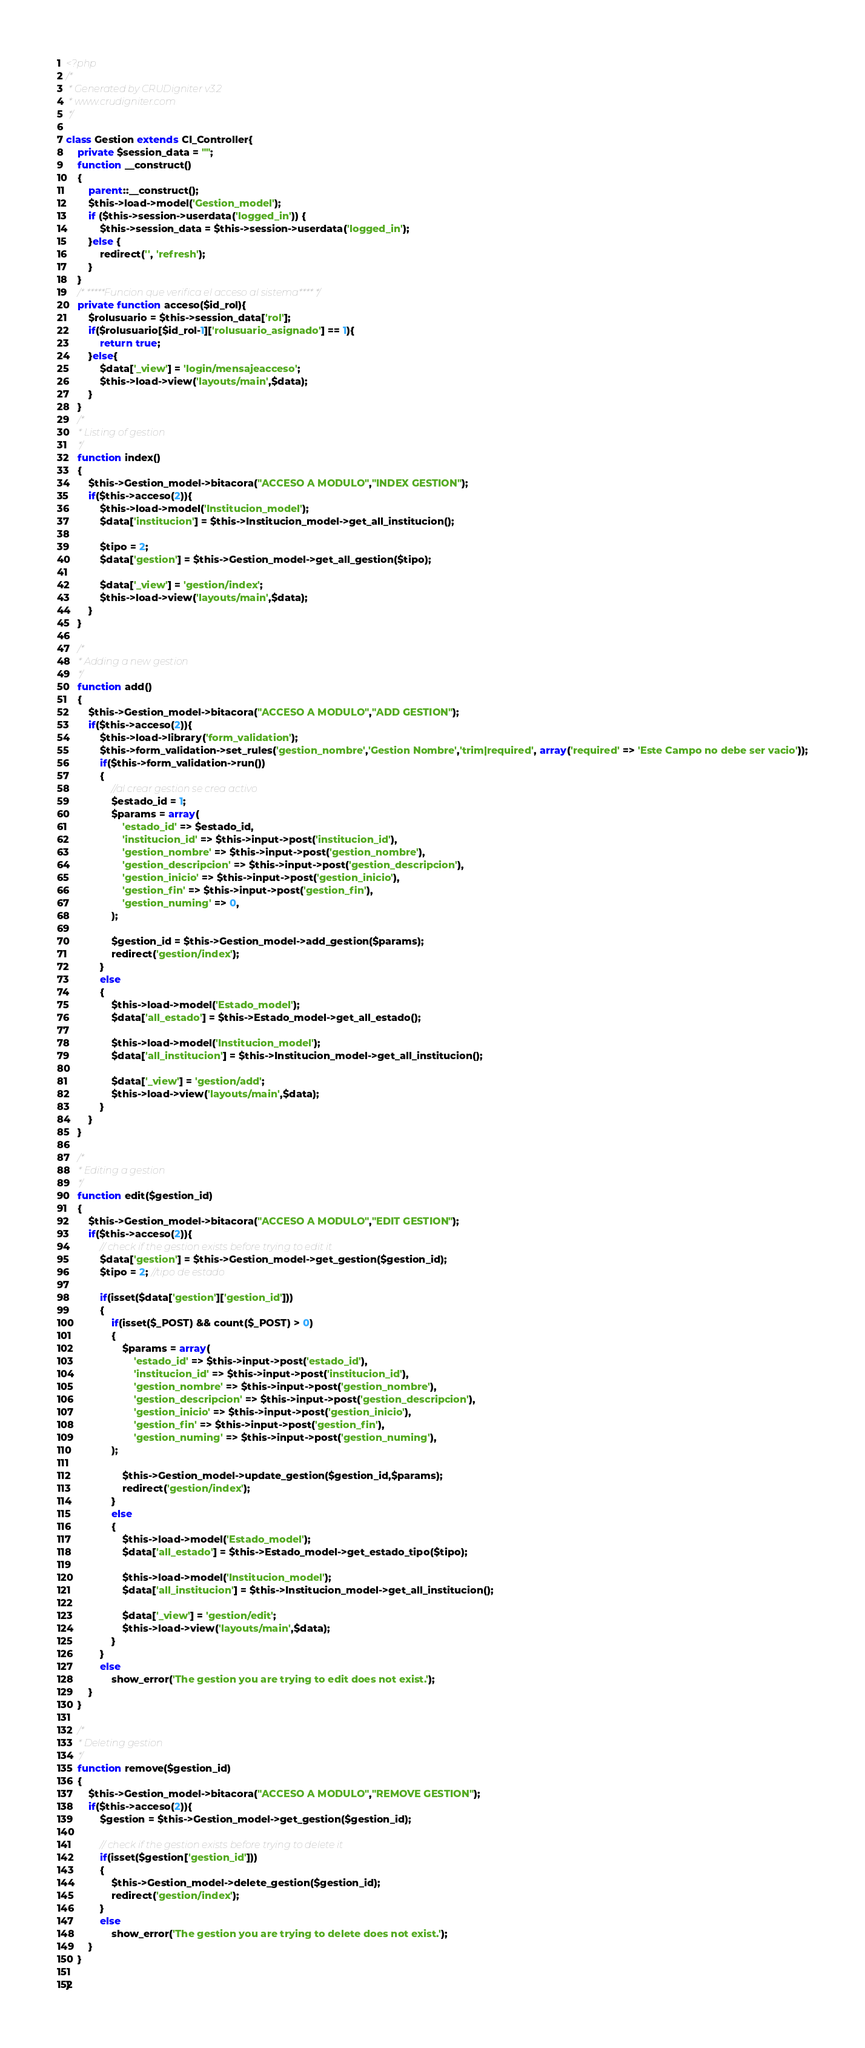Convert code to text. <code><loc_0><loc_0><loc_500><loc_500><_PHP_><?php
/* 
 * Generated by CRUDigniter v3.2 
 * www.crudigniter.com
 */
 
class Gestion extends CI_Controller{
    private $session_data = "";
    function __construct()
    {
        parent::__construct();
        $this->load->model('Gestion_model');
        if ($this->session->userdata('logged_in')) {
            $this->session_data = $this->session->userdata('logged_in');
        }else {
            redirect('', 'refresh');
        }
    } 
    /* *****Funcion que verifica el acceso al sistema**** */
    private function acceso($id_rol){
        $rolusuario = $this->session_data['rol'];
        if($rolusuario[$id_rol-1]['rolusuario_asignado'] == 1){
            return true;
        }else{
            $data['_view'] = 'login/mensajeacceso';
            $this->load->view('layouts/main',$data);
        }
    }
    /*
     * Listing of gestion
     */
    function index()
    {
        $this->Gestion_model->bitacora("ACCESO A MODULO","INDEX GESTION");
        if($this->acceso(2)){
            $this->load->model('Institucion_model');
            $data['institucion'] = $this->Institucion_model->get_all_institucion();

            $tipo = 2;
            $data['gestion'] = $this->Gestion_model->get_all_gestion($tipo);

            $data['_view'] = 'gestion/index';
            $this->load->view('layouts/main',$data);
        }
    }

    /*
     * Adding a new gestion
     */
    function add()
    {
        $this->Gestion_model->bitacora("ACCESO A MODULO","ADD GESTION");
        if($this->acceso(2)){
            $this->load->library('form_validation');
            $this->form_validation->set_rules('gestion_nombre','Gestion Nombre','trim|required', array('required' => 'Este Campo no debe ser vacio'));
            if($this->form_validation->run())     
            {
                //al crear gestion se crea activo
                $estado_id = 1;
                $params = array(
                    'estado_id' => $estado_id,
                    'institucion_id' => $this->input->post('institucion_id'),
                    'gestion_nombre' => $this->input->post('gestion_nombre'),
                    'gestion_descripcion' => $this->input->post('gestion_descripcion'),
                    'gestion_inicio' => $this->input->post('gestion_inicio'),
                    'gestion_fin' => $this->input->post('gestion_fin'),
                    'gestion_numing' => 0,
                );

                $gestion_id = $this->Gestion_model->add_gestion($params);
                redirect('gestion/index');
            }
            else
            {
                $this->load->model('Estado_model');
                $data['all_estado'] = $this->Estado_model->get_all_estado();

                $this->load->model('Institucion_model');
                $data['all_institucion'] = $this->Institucion_model->get_all_institucion();

                $data['_view'] = 'gestion/add';
                $this->load->view('layouts/main',$data);
            }
        }
    }  

    /*
     * Editing a gestion
     */
    function edit($gestion_id)
    {
        $this->Gestion_model->bitacora("ACCESO A MODULO","EDIT GESTION");
        if($this->acceso(2)){
            // check if the gestion exists before trying to edit it
            $data['gestion'] = $this->Gestion_model->get_gestion($gestion_id);
            $tipo = 2; //tipo de estado

            if(isset($data['gestion']['gestion_id']))
            {
                if(isset($_POST) && count($_POST) > 0)     
                {   
                    $params = array(
                        'estado_id' => $this->input->post('estado_id'),
                        'institucion_id' => $this->input->post('institucion_id'),
                        'gestion_nombre' => $this->input->post('gestion_nombre'),
                        'gestion_descripcion' => $this->input->post('gestion_descripcion'),
                        'gestion_inicio' => $this->input->post('gestion_inicio'),
                        'gestion_fin' => $this->input->post('gestion_fin'),
                        'gestion_numing' => $this->input->post('gestion_numing'),
                );

                    $this->Gestion_model->update_gestion($gestion_id,$params);            
                    redirect('gestion/index');
                }
                else
                {
                    $this->load->model('Estado_model');
                    $data['all_estado'] = $this->Estado_model->get_estado_tipo($tipo);

                    $this->load->model('Institucion_model');
                    $data['all_institucion'] = $this->Institucion_model->get_all_institucion();

                    $data['_view'] = 'gestion/edit';
                    $this->load->view('layouts/main',$data);
                }
            }
            else
                show_error('The gestion you are trying to edit does not exist.');
        }
    } 

    /*
     * Deleting gestion
     */
    function remove($gestion_id)
    {
        $this->Gestion_model->bitacora("ACCESO A MODULO","REMOVE GESTION");
        if($this->acceso(2)){
            $gestion = $this->Gestion_model->get_gestion($gestion_id);

            // check if the gestion exists before trying to delete it
            if(isset($gestion['gestion_id']))
            {
                $this->Gestion_model->delete_gestion($gestion_id);
                redirect('gestion/index');
            }
            else
                show_error('The gestion you are trying to delete does not exist.');
        }
    }
    
}
</code> 